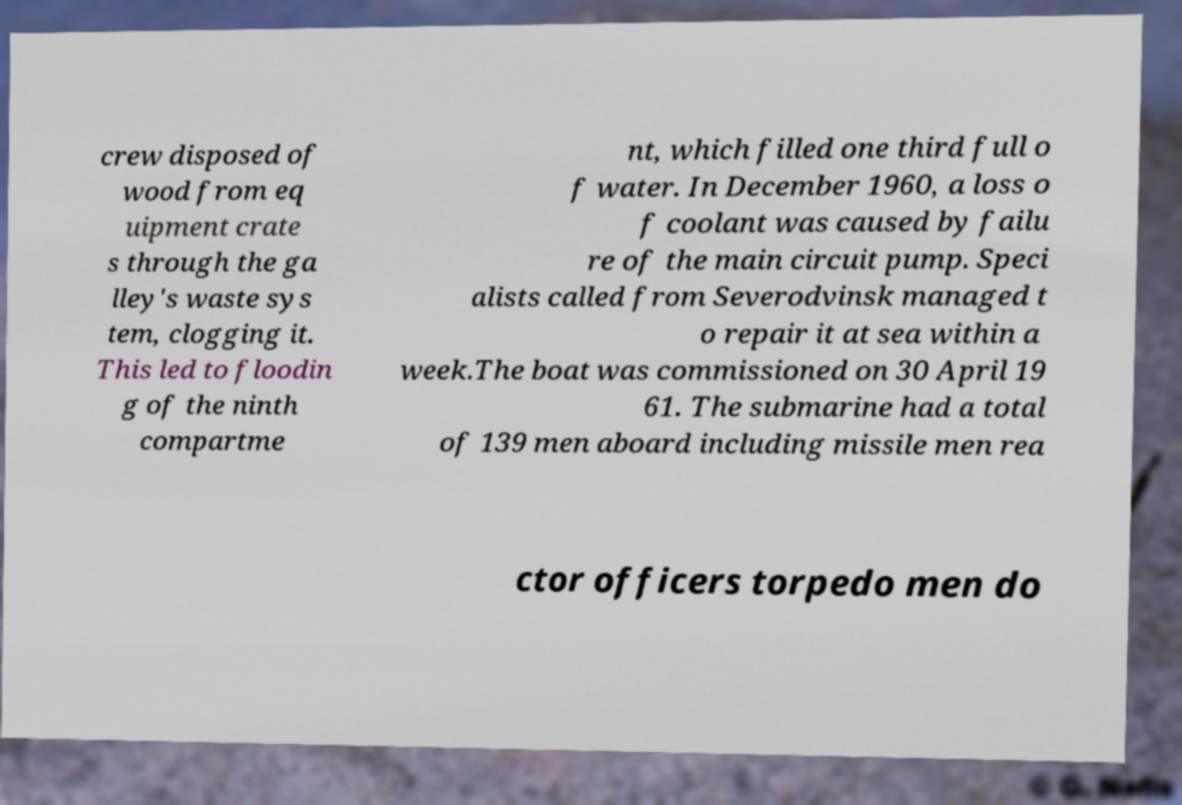Could you extract and type out the text from this image? crew disposed of wood from eq uipment crate s through the ga lley's waste sys tem, clogging it. This led to floodin g of the ninth compartme nt, which filled one third full o f water. In December 1960, a loss o f coolant was caused by failu re of the main circuit pump. Speci alists called from Severodvinsk managed t o repair it at sea within a week.The boat was commissioned on 30 April 19 61. The submarine had a total of 139 men aboard including missile men rea ctor officers torpedo men do 